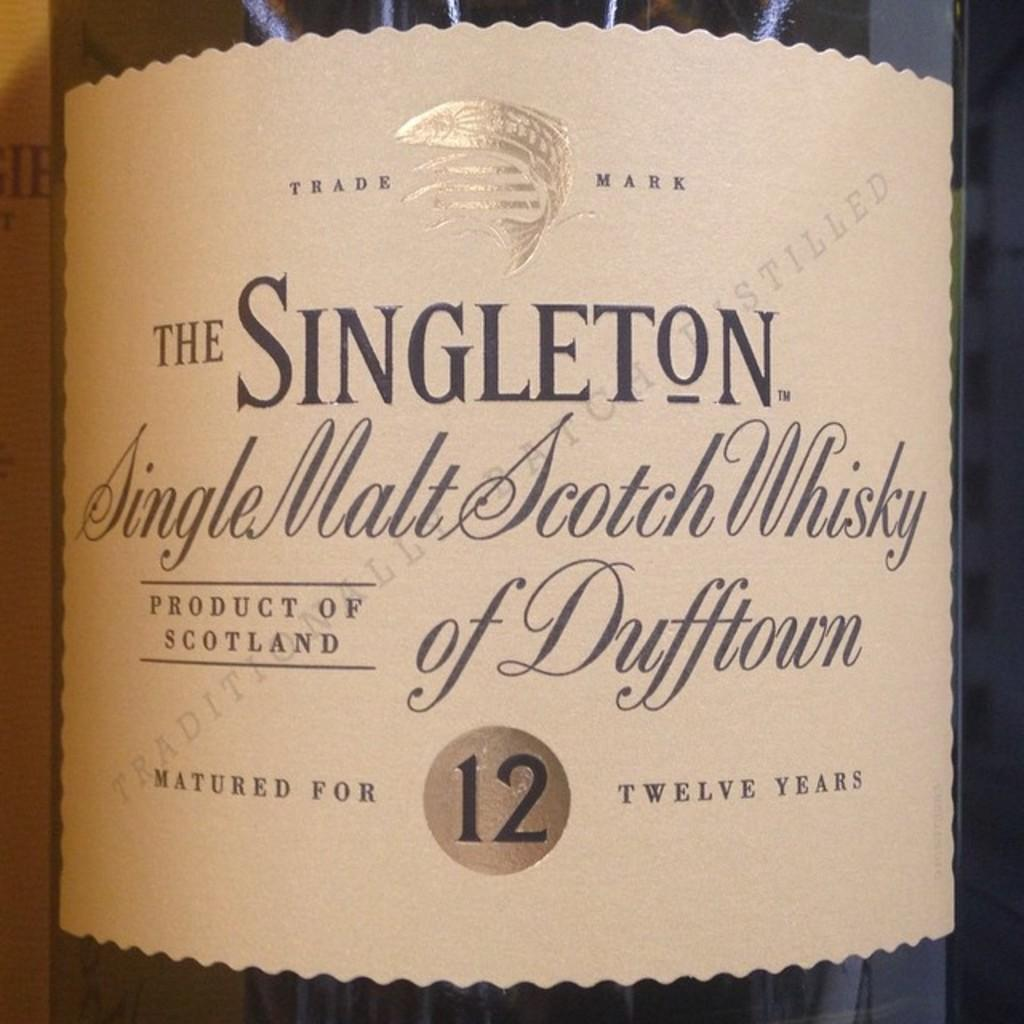<image>
Create a compact narrative representing the image presented. A bottle of Singleton Single Malt Scotch Whisky. 